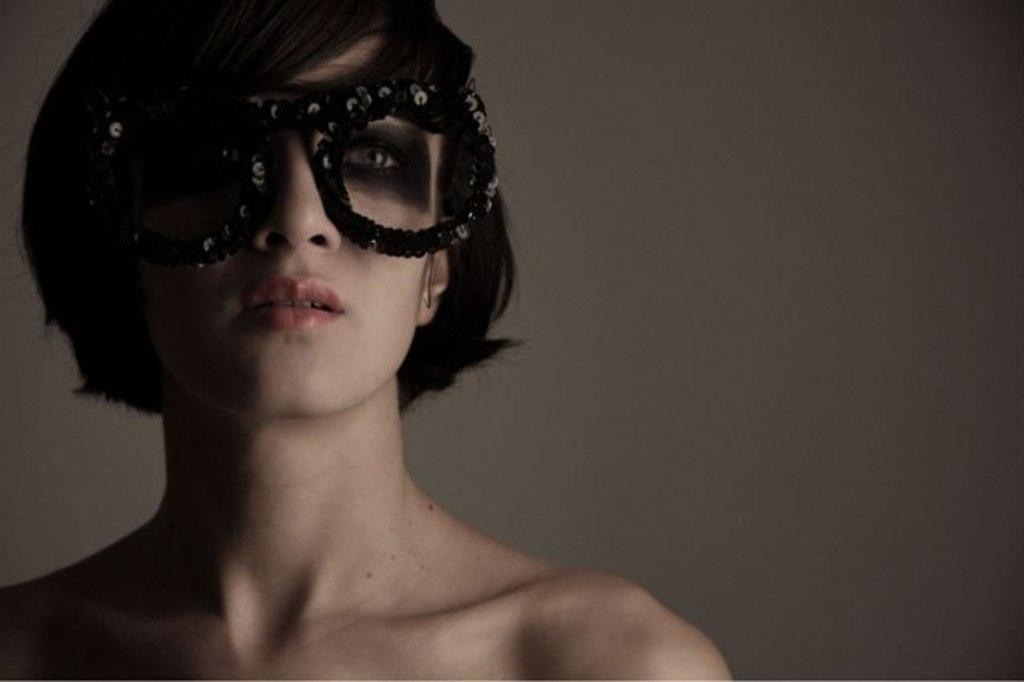Who is the main subject in the image? There is a lady in the center of the image. What is the lady wearing on her face? The lady is wearing goggles. What can be seen in the background of the image? There is a wall in the background of the image. What type of brass instrument is the lady playing in the image? There is no brass instrument present in the image; the lady is wearing goggles. 